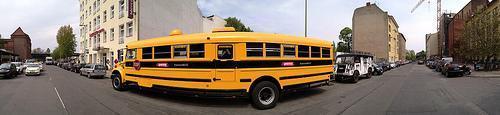How many buses are there?
Give a very brief answer. 1. 